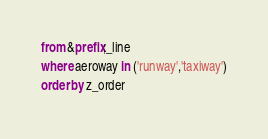<code> <loc_0><loc_0><loc_500><loc_500><_SQL_>from &prefix;_line
where aeroway in ('runway','taxiway')
order by z_order
</code> 